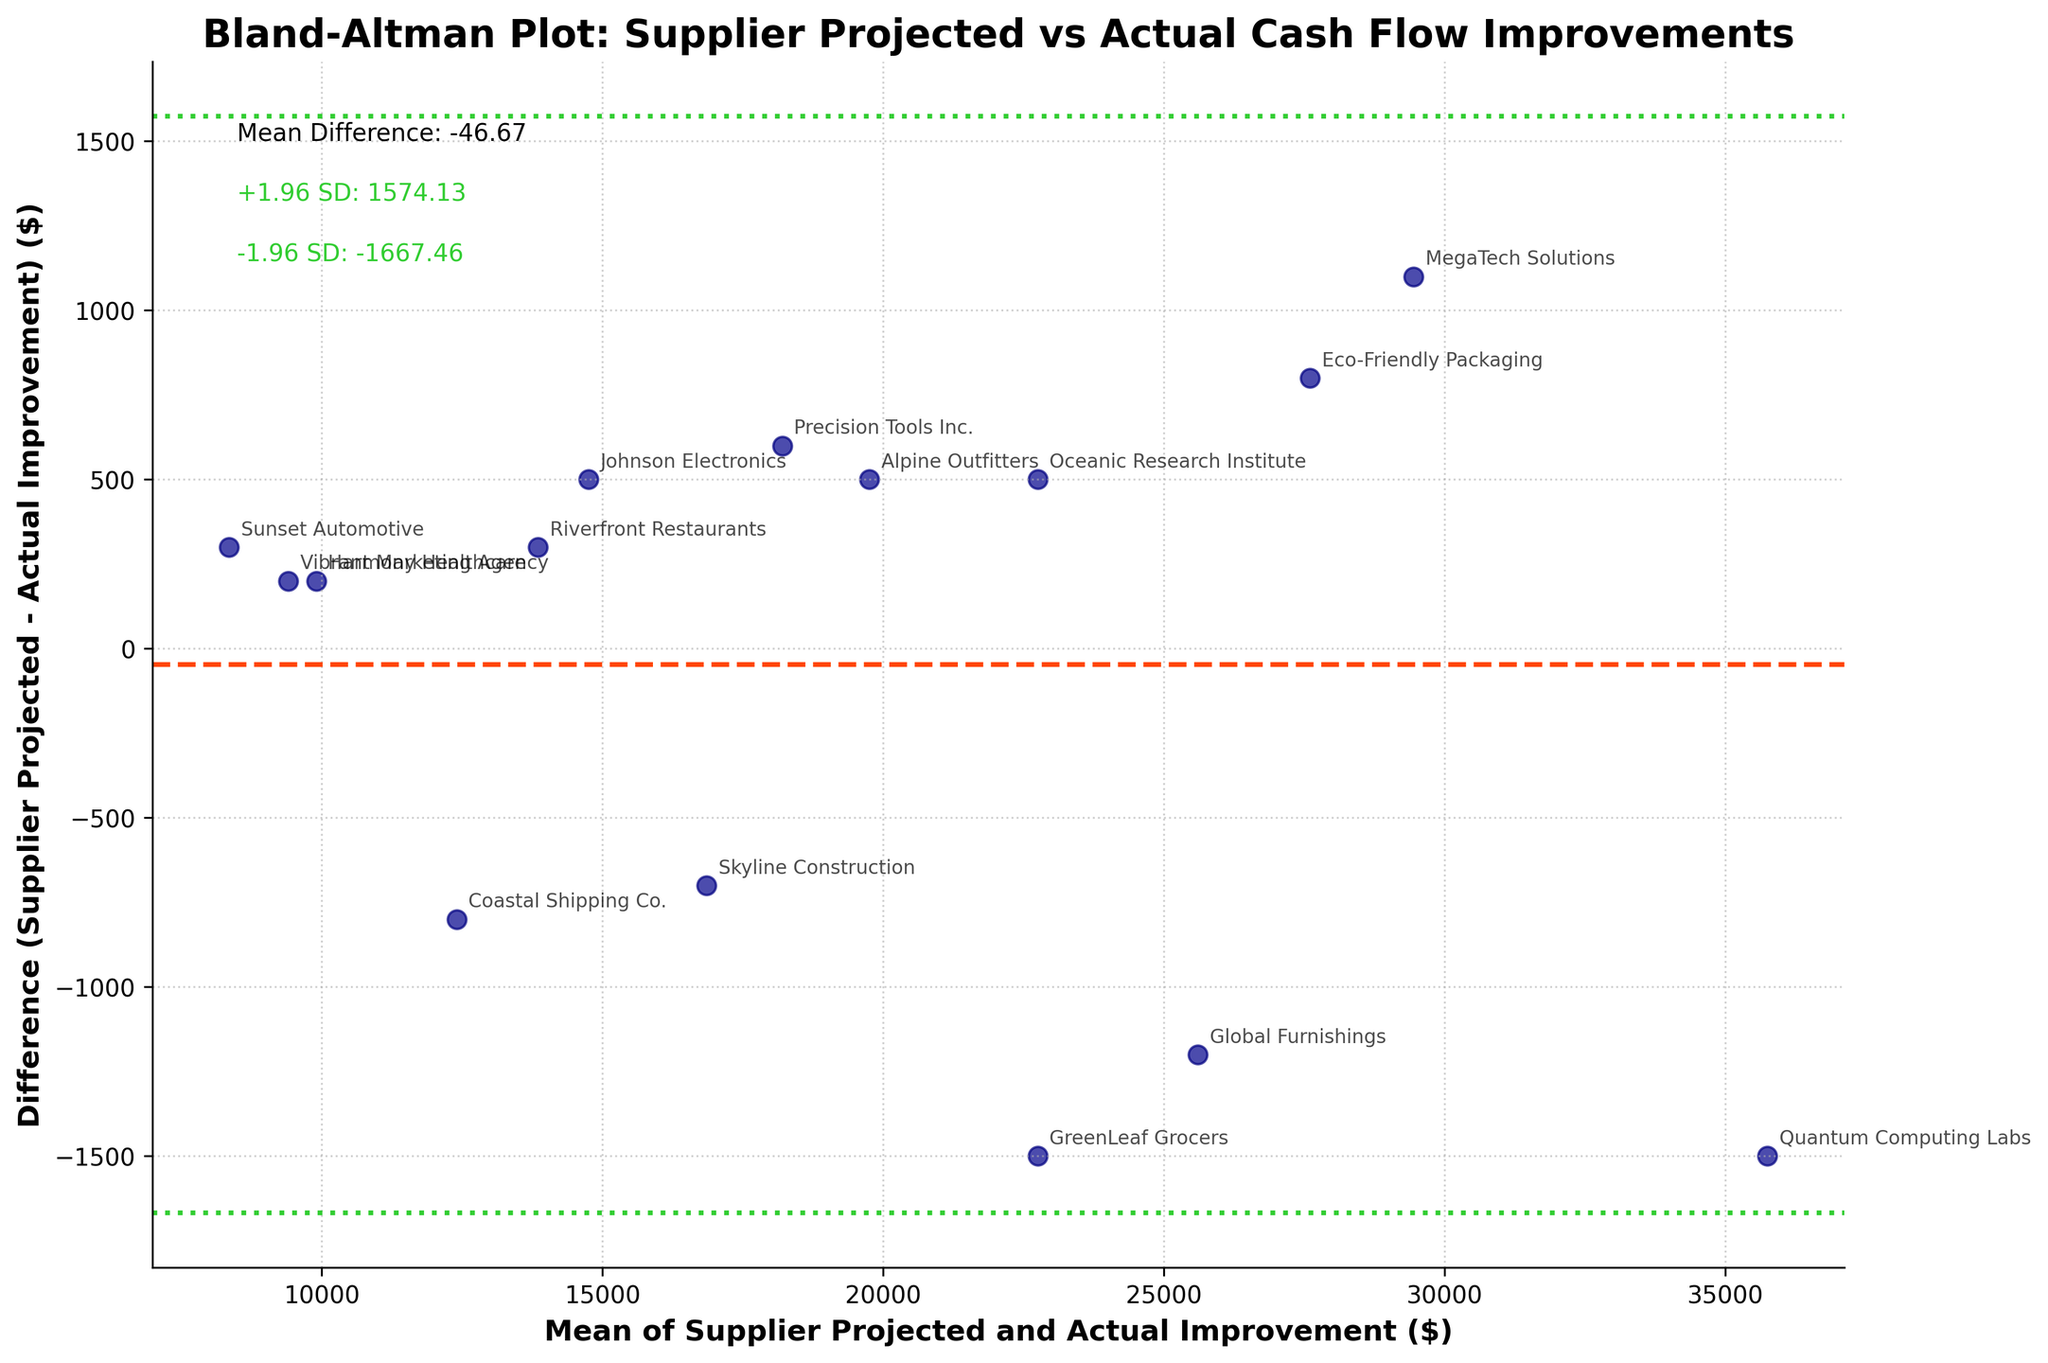What does the title of the plot indicate? The title provides context for the plot, indicating it is a Bland-Altman plot that compares supplier-projected versus actual cash flow improvements. This hints that the plot will help evaluate the agreement between the two sets of measurements.
Answer: It compares supplier-projected versus actual cash flow improvements How many clients are included in the plot? By counting the number of data points (scatter points) in the figure, one can determine the number of clients. Each point represents a client. Additionally, each annotation with the client name confirms their presence.
Answer: 15 What is the mean difference between supplier-projected and actual improvements? The mean difference is indicated by the central horizontal line (colored in orangered) and annotated in the figure. It is labeled as "Mean Difference" with a specific numeric value provided.
Answer: -130.00 What do the green dashed lines represent? The green dashed lines indicate the limits of agreement, calculated as the mean difference plus and minus 1.96 times the standard deviation of the differences. These lines are meant to show the range within which most differences should lie.
Answer: Limits of agreement (Mean Difference ± 1.96 SD) Which client has the largest positive difference between projected and actual improvements? To identify the client with the largest positive difference, we look for the data point that is highest above the zero line (x-axis). The corresponding annotation will provide the client’s name.
Answer: Global Furnishings What is the mean value of supplier-projected and actual improvement for Quantum Computing Labs? To find the mean value of supplier-projected and actual improvements, locate the point marked "Quantum Computing Labs". The horizontal position of this point represents the average of the supplier-projected and actual values. From the data, it is (35000 + 36500) / 2.
Answer: 35750 Is the actual improvement generally higher, lower, or about the same as the supplier-projected improvement across clients? By examining the distribution of points around the horizontal zero line, if most points are below this line, supplier projections are generally higher; if above, actual improvements are higher; if they lie on the zero line, they match.
Answer: About the same Which pair of improvements (supplier-projected and actual) shows the smallest absolute difference? To determine which client has the smallest absolute difference between supplier-projected and actual, find the point closest to the zero difference line. Since the point is annotated, the client name can be directly observed.
Answer: Vibrant Marketing Agency What is the range of differences observed among the clients? The range of differences can be understood by looking at the highest and lowest points on the y-axis and noting the values corresponding to the limits of agreement lines. This shows the spread of differences between the supplier-projected and actual improvements.
Answer: -3000 to 2500 Is there a consistent bias in the supplier's projections? Consistency in bias would appear if the mean difference line is significantly above or below the zero line. Observing the horizontal line and its annotated value can determine if there is a consistent overestimation or underestimation.
Answer: Slight underestimation 